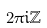Convert formula to latex. <formula><loc_0><loc_0><loc_500><loc_500>2 \pi i \mathbb { Z }</formula> 